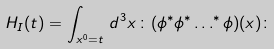Convert formula to latex. <formula><loc_0><loc_0><loc_500><loc_500>H _ { I } ( t ) = \int _ { x ^ { 0 } = t } \, d ^ { 3 } x \, \colon ( \phi ^ { * } \phi ^ { * } \dots ^ { * } \phi ) ( x ) \colon</formula> 